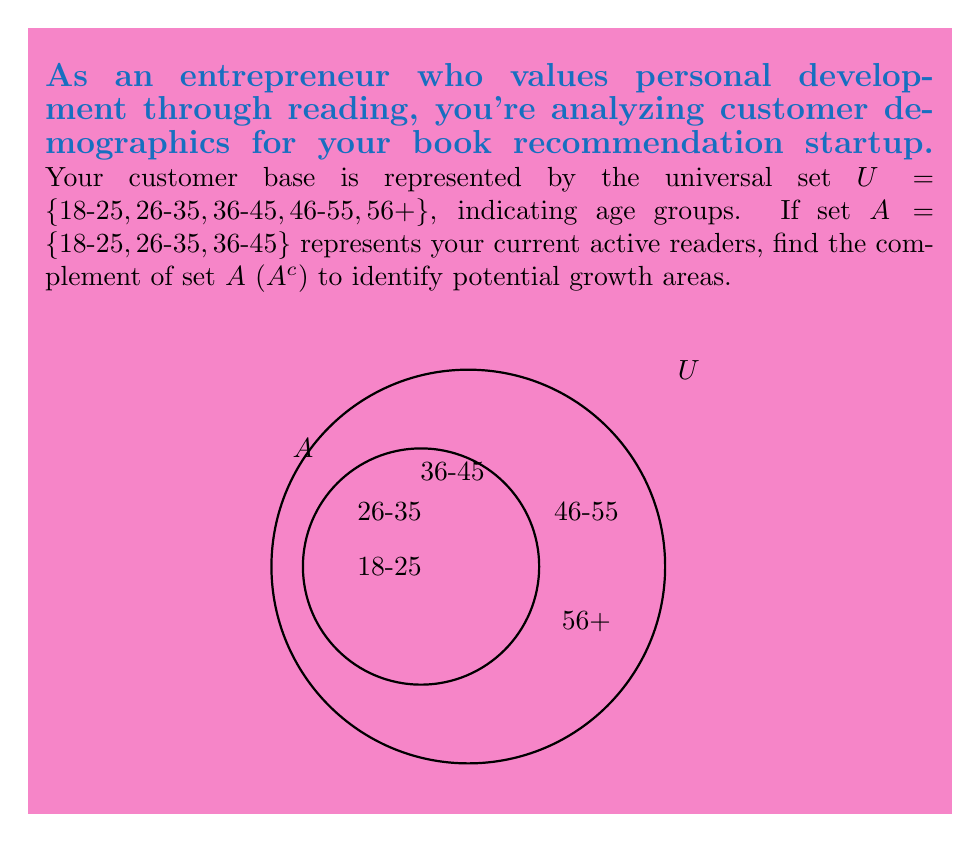Can you answer this question? To find the complement of set $A$ ($A^c$), we need to identify all elements in the universal set $U$ that are not in set $A$. Let's follow these steps:

1) First, let's recall the definition of set complement:
   $A^c = \{x \in U : x \notin A\}$

2) We know:
   $U = \{18-25, 26-35, 36-45, 46-55, 56+\}$
   $A = \{18-25, 26-35, 36-45\}$

3) To find $A^c$, we need to identify the elements in $U$ that are not in $A$:
   $46-55 \in U$ but $46-55 \notin A$
   $56+ \in U$ but $56+ \notin A$

4) Therefore, the complement of $A$ is:
   $A^c = \{46-55, 56+\}$

This result shows the age groups that are not currently active readers, representing potential growth areas for your book recommendation startup.
Answer: $A^c = \{46-55, 56+\}$ 